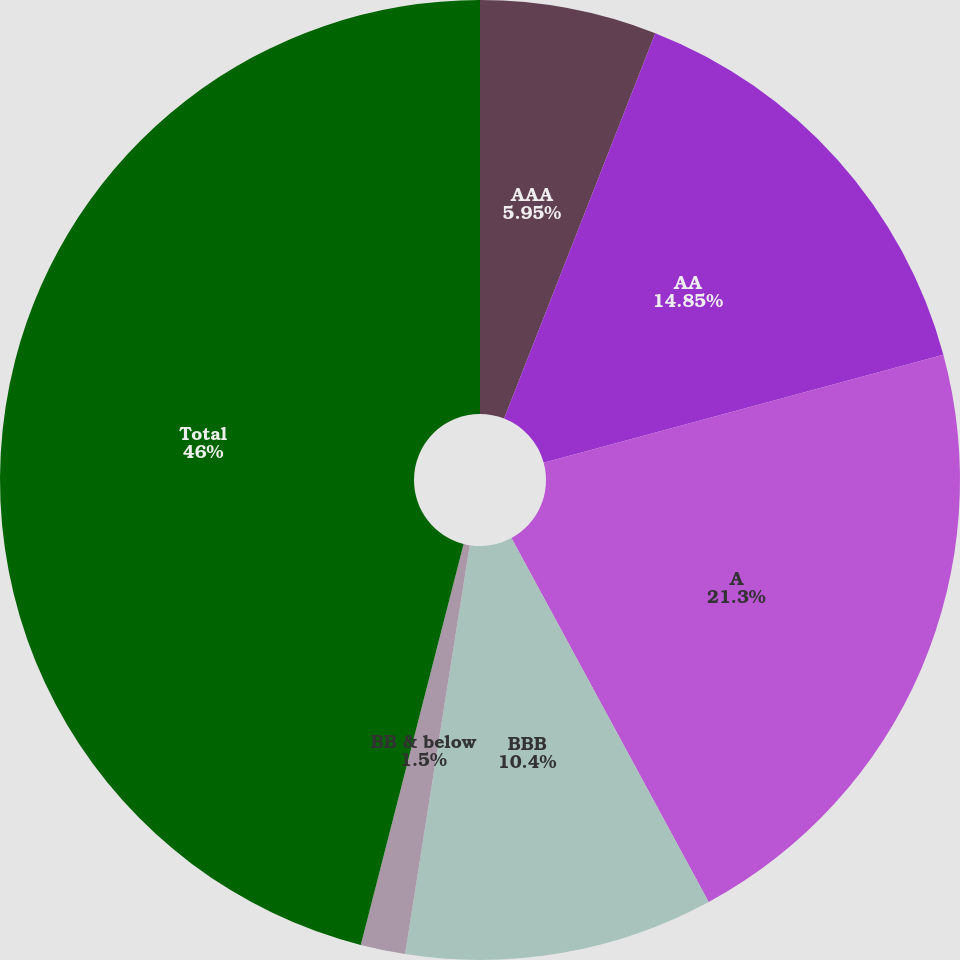Convert chart to OTSL. <chart><loc_0><loc_0><loc_500><loc_500><pie_chart><fcel>AAA<fcel>AA<fcel>A<fcel>BBB<fcel>BB & below<fcel>Total<nl><fcel>5.95%<fcel>14.85%<fcel>21.3%<fcel>10.4%<fcel>1.5%<fcel>46.01%<nl></chart> 